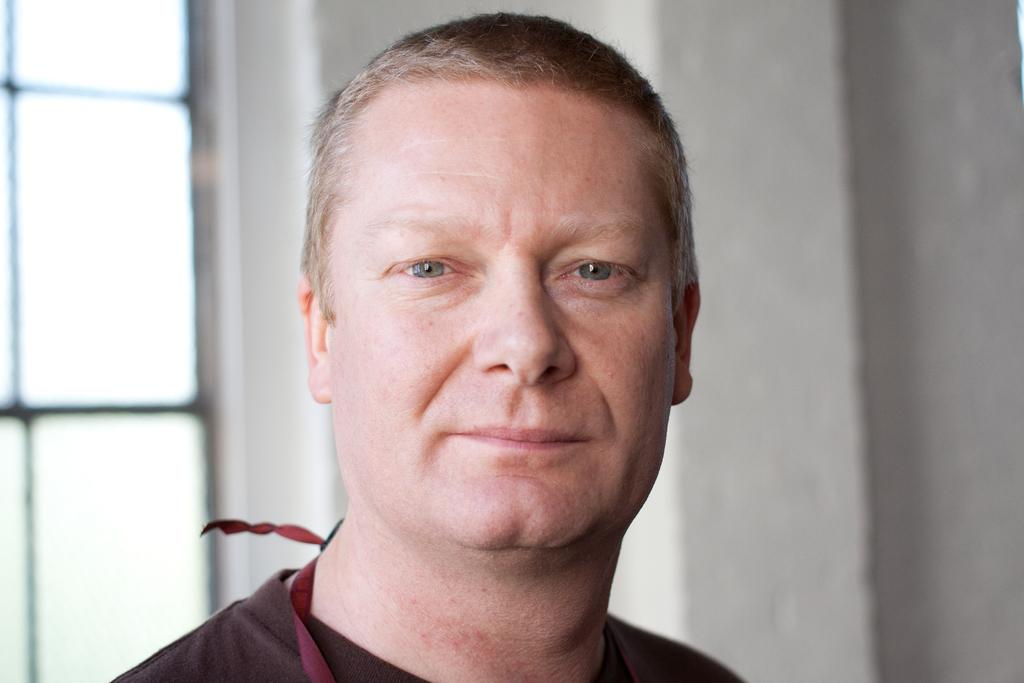What is the main subject in the center of the image? There are persons' faces in the center of the image. What can be seen in the background of the image? There is a window and a wall in the background of the image. What type of drum is being played in the image? There is no drum present in the image; it features persons' faces and a background with a window and a wall. What reward is being given to the person in the image? There is no reward being given in the image; it only shows persons' faces and a background with a window and a wall. 